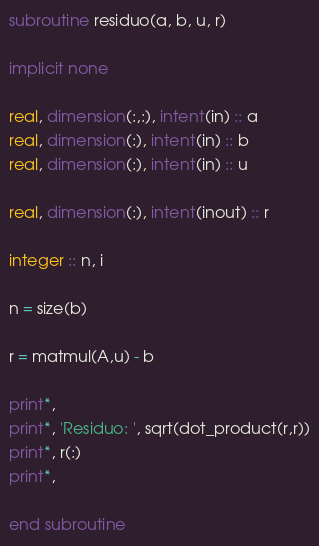<code> <loc_0><loc_0><loc_500><loc_500><_FORTRAN_>subroutine residuo(a, b, u, r)

implicit none

real, dimension(:,:), intent(in) :: a
real, dimension(:), intent(in) :: b
real, dimension(:), intent(in) :: u

real, dimension(:), intent(inout) :: r

integer :: n, i

n = size(b)

r = matmul(A,u) - b

print*,
print*, 'Residuo: ', sqrt(dot_product(r,r))
print*, r(:)
print*,

end subroutine
</code> 